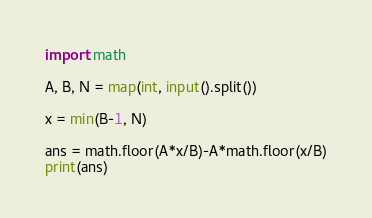Convert code to text. <code><loc_0><loc_0><loc_500><loc_500><_Python_>import math
 
A, B, N = map(int, input().split())

x = min(B-1, N)

ans = math.floor(A*x/B)-A*math.floor(x/B)
print(ans)</code> 